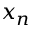<formula> <loc_0><loc_0><loc_500><loc_500>x _ { n }</formula> 